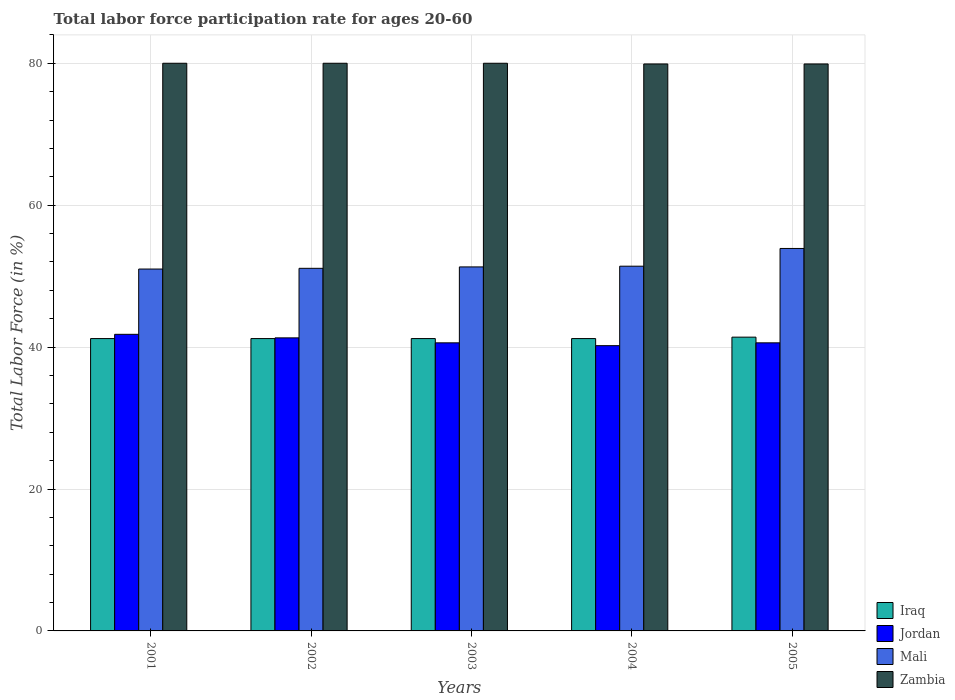How many bars are there on the 4th tick from the right?
Offer a terse response. 4. What is the labor force participation rate in Iraq in 2004?
Give a very brief answer. 41.2. Across all years, what is the maximum labor force participation rate in Iraq?
Your answer should be compact. 41.4. Across all years, what is the minimum labor force participation rate in Jordan?
Keep it short and to the point. 40.2. In which year was the labor force participation rate in Mali minimum?
Offer a terse response. 2001. What is the total labor force participation rate in Iraq in the graph?
Your response must be concise. 206.2. What is the difference between the labor force participation rate in Jordan in 2002 and that in 2005?
Your answer should be very brief. 0.7. What is the difference between the labor force participation rate in Zambia in 2001 and the labor force participation rate in Jordan in 2004?
Offer a terse response. 39.8. What is the average labor force participation rate in Iraq per year?
Your answer should be compact. 41.24. In the year 2003, what is the difference between the labor force participation rate in Mali and labor force participation rate in Jordan?
Keep it short and to the point. 10.7. What is the ratio of the labor force participation rate in Zambia in 2002 to that in 2005?
Offer a very short reply. 1. What is the difference between the highest and the second highest labor force participation rate in Iraq?
Your response must be concise. 0.2. What is the difference between the highest and the lowest labor force participation rate in Zambia?
Your answer should be very brief. 0.1. Is the sum of the labor force participation rate in Zambia in 2004 and 2005 greater than the maximum labor force participation rate in Mali across all years?
Your response must be concise. Yes. Is it the case that in every year, the sum of the labor force participation rate in Zambia and labor force participation rate in Jordan is greater than the sum of labor force participation rate in Mali and labor force participation rate in Iraq?
Ensure brevity in your answer.  Yes. What does the 1st bar from the left in 2005 represents?
Your answer should be very brief. Iraq. What does the 4th bar from the right in 2004 represents?
Offer a very short reply. Iraq. Is it the case that in every year, the sum of the labor force participation rate in Iraq and labor force participation rate in Mali is greater than the labor force participation rate in Jordan?
Provide a short and direct response. Yes. How many bars are there?
Provide a short and direct response. 20. Are all the bars in the graph horizontal?
Give a very brief answer. No. How many years are there in the graph?
Your answer should be very brief. 5. What is the difference between two consecutive major ticks on the Y-axis?
Provide a short and direct response. 20. Does the graph contain any zero values?
Offer a very short reply. No. How many legend labels are there?
Offer a very short reply. 4. How are the legend labels stacked?
Keep it short and to the point. Vertical. What is the title of the graph?
Keep it short and to the point. Total labor force participation rate for ages 20-60. Does "Trinidad and Tobago" appear as one of the legend labels in the graph?
Offer a very short reply. No. What is the label or title of the X-axis?
Your response must be concise. Years. What is the Total Labor Force (in %) of Iraq in 2001?
Ensure brevity in your answer.  41.2. What is the Total Labor Force (in %) in Jordan in 2001?
Your response must be concise. 41.8. What is the Total Labor Force (in %) of Iraq in 2002?
Keep it short and to the point. 41.2. What is the Total Labor Force (in %) in Jordan in 2002?
Your answer should be very brief. 41.3. What is the Total Labor Force (in %) in Mali in 2002?
Your answer should be very brief. 51.1. What is the Total Labor Force (in %) of Iraq in 2003?
Offer a very short reply. 41.2. What is the Total Labor Force (in %) in Jordan in 2003?
Keep it short and to the point. 40.6. What is the Total Labor Force (in %) in Mali in 2003?
Provide a short and direct response. 51.3. What is the Total Labor Force (in %) in Zambia in 2003?
Offer a very short reply. 80. What is the Total Labor Force (in %) of Iraq in 2004?
Ensure brevity in your answer.  41.2. What is the Total Labor Force (in %) of Jordan in 2004?
Your response must be concise. 40.2. What is the Total Labor Force (in %) in Mali in 2004?
Provide a succinct answer. 51.4. What is the Total Labor Force (in %) in Zambia in 2004?
Offer a very short reply. 79.9. What is the Total Labor Force (in %) of Iraq in 2005?
Provide a succinct answer. 41.4. What is the Total Labor Force (in %) of Jordan in 2005?
Your response must be concise. 40.6. What is the Total Labor Force (in %) in Mali in 2005?
Offer a terse response. 53.9. What is the Total Labor Force (in %) in Zambia in 2005?
Offer a terse response. 79.9. Across all years, what is the maximum Total Labor Force (in %) in Iraq?
Your answer should be compact. 41.4. Across all years, what is the maximum Total Labor Force (in %) in Jordan?
Offer a terse response. 41.8. Across all years, what is the maximum Total Labor Force (in %) in Mali?
Your answer should be very brief. 53.9. Across all years, what is the maximum Total Labor Force (in %) of Zambia?
Offer a very short reply. 80. Across all years, what is the minimum Total Labor Force (in %) of Iraq?
Offer a terse response. 41.2. Across all years, what is the minimum Total Labor Force (in %) of Jordan?
Provide a succinct answer. 40.2. Across all years, what is the minimum Total Labor Force (in %) in Mali?
Your answer should be very brief. 51. Across all years, what is the minimum Total Labor Force (in %) of Zambia?
Give a very brief answer. 79.9. What is the total Total Labor Force (in %) in Iraq in the graph?
Keep it short and to the point. 206.2. What is the total Total Labor Force (in %) in Jordan in the graph?
Your response must be concise. 204.5. What is the total Total Labor Force (in %) in Mali in the graph?
Offer a very short reply. 258.7. What is the total Total Labor Force (in %) of Zambia in the graph?
Your answer should be compact. 399.8. What is the difference between the Total Labor Force (in %) of Iraq in 2001 and that in 2002?
Offer a very short reply. 0. What is the difference between the Total Labor Force (in %) in Jordan in 2001 and that in 2002?
Keep it short and to the point. 0.5. What is the difference between the Total Labor Force (in %) in Mali in 2001 and that in 2002?
Your answer should be compact. -0.1. What is the difference between the Total Labor Force (in %) in Zambia in 2001 and that in 2003?
Ensure brevity in your answer.  0. What is the difference between the Total Labor Force (in %) in Mali in 2001 and that in 2004?
Your answer should be very brief. -0.4. What is the difference between the Total Labor Force (in %) in Iraq in 2001 and that in 2005?
Ensure brevity in your answer.  -0.2. What is the difference between the Total Labor Force (in %) of Jordan in 2001 and that in 2005?
Give a very brief answer. 1.2. What is the difference between the Total Labor Force (in %) of Mali in 2001 and that in 2005?
Offer a very short reply. -2.9. What is the difference between the Total Labor Force (in %) in Jordan in 2002 and that in 2003?
Your answer should be very brief. 0.7. What is the difference between the Total Labor Force (in %) in Zambia in 2002 and that in 2003?
Your answer should be compact. 0. What is the difference between the Total Labor Force (in %) of Iraq in 2002 and that in 2004?
Your answer should be very brief. 0. What is the difference between the Total Labor Force (in %) in Jordan in 2002 and that in 2004?
Provide a short and direct response. 1.1. What is the difference between the Total Labor Force (in %) of Mali in 2002 and that in 2004?
Make the answer very short. -0.3. What is the difference between the Total Labor Force (in %) of Mali in 2002 and that in 2005?
Offer a very short reply. -2.8. What is the difference between the Total Labor Force (in %) of Zambia in 2002 and that in 2005?
Give a very brief answer. 0.1. What is the difference between the Total Labor Force (in %) in Iraq in 2003 and that in 2004?
Your answer should be very brief. 0. What is the difference between the Total Labor Force (in %) in Jordan in 2003 and that in 2004?
Your response must be concise. 0.4. What is the difference between the Total Labor Force (in %) of Mali in 2003 and that in 2004?
Ensure brevity in your answer.  -0.1. What is the difference between the Total Labor Force (in %) of Zambia in 2003 and that in 2004?
Your answer should be very brief. 0.1. What is the difference between the Total Labor Force (in %) in Zambia in 2003 and that in 2005?
Provide a succinct answer. 0.1. What is the difference between the Total Labor Force (in %) in Jordan in 2004 and that in 2005?
Your answer should be very brief. -0.4. What is the difference between the Total Labor Force (in %) of Zambia in 2004 and that in 2005?
Make the answer very short. 0. What is the difference between the Total Labor Force (in %) in Iraq in 2001 and the Total Labor Force (in %) in Zambia in 2002?
Provide a succinct answer. -38.8. What is the difference between the Total Labor Force (in %) of Jordan in 2001 and the Total Labor Force (in %) of Zambia in 2002?
Provide a succinct answer. -38.2. What is the difference between the Total Labor Force (in %) in Iraq in 2001 and the Total Labor Force (in %) in Jordan in 2003?
Your answer should be very brief. 0.6. What is the difference between the Total Labor Force (in %) in Iraq in 2001 and the Total Labor Force (in %) in Zambia in 2003?
Ensure brevity in your answer.  -38.8. What is the difference between the Total Labor Force (in %) of Jordan in 2001 and the Total Labor Force (in %) of Zambia in 2003?
Offer a very short reply. -38.2. What is the difference between the Total Labor Force (in %) in Mali in 2001 and the Total Labor Force (in %) in Zambia in 2003?
Your response must be concise. -29. What is the difference between the Total Labor Force (in %) of Iraq in 2001 and the Total Labor Force (in %) of Mali in 2004?
Make the answer very short. -10.2. What is the difference between the Total Labor Force (in %) of Iraq in 2001 and the Total Labor Force (in %) of Zambia in 2004?
Keep it short and to the point. -38.7. What is the difference between the Total Labor Force (in %) in Jordan in 2001 and the Total Labor Force (in %) in Zambia in 2004?
Your response must be concise. -38.1. What is the difference between the Total Labor Force (in %) in Mali in 2001 and the Total Labor Force (in %) in Zambia in 2004?
Your response must be concise. -28.9. What is the difference between the Total Labor Force (in %) in Iraq in 2001 and the Total Labor Force (in %) in Zambia in 2005?
Keep it short and to the point. -38.7. What is the difference between the Total Labor Force (in %) in Jordan in 2001 and the Total Labor Force (in %) in Zambia in 2005?
Your response must be concise. -38.1. What is the difference between the Total Labor Force (in %) in Mali in 2001 and the Total Labor Force (in %) in Zambia in 2005?
Offer a very short reply. -28.9. What is the difference between the Total Labor Force (in %) in Iraq in 2002 and the Total Labor Force (in %) in Jordan in 2003?
Provide a succinct answer. 0.6. What is the difference between the Total Labor Force (in %) in Iraq in 2002 and the Total Labor Force (in %) in Mali in 2003?
Give a very brief answer. -10.1. What is the difference between the Total Labor Force (in %) of Iraq in 2002 and the Total Labor Force (in %) of Zambia in 2003?
Your answer should be compact. -38.8. What is the difference between the Total Labor Force (in %) in Jordan in 2002 and the Total Labor Force (in %) in Zambia in 2003?
Your response must be concise. -38.7. What is the difference between the Total Labor Force (in %) in Mali in 2002 and the Total Labor Force (in %) in Zambia in 2003?
Make the answer very short. -28.9. What is the difference between the Total Labor Force (in %) of Iraq in 2002 and the Total Labor Force (in %) of Zambia in 2004?
Provide a succinct answer. -38.7. What is the difference between the Total Labor Force (in %) of Jordan in 2002 and the Total Labor Force (in %) of Zambia in 2004?
Provide a succinct answer. -38.6. What is the difference between the Total Labor Force (in %) of Mali in 2002 and the Total Labor Force (in %) of Zambia in 2004?
Provide a short and direct response. -28.8. What is the difference between the Total Labor Force (in %) in Iraq in 2002 and the Total Labor Force (in %) in Mali in 2005?
Ensure brevity in your answer.  -12.7. What is the difference between the Total Labor Force (in %) in Iraq in 2002 and the Total Labor Force (in %) in Zambia in 2005?
Ensure brevity in your answer.  -38.7. What is the difference between the Total Labor Force (in %) of Jordan in 2002 and the Total Labor Force (in %) of Zambia in 2005?
Your answer should be compact. -38.6. What is the difference between the Total Labor Force (in %) of Mali in 2002 and the Total Labor Force (in %) of Zambia in 2005?
Your response must be concise. -28.8. What is the difference between the Total Labor Force (in %) in Iraq in 2003 and the Total Labor Force (in %) in Zambia in 2004?
Offer a very short reply. -38.7. What is the difference between the Total Labor Force (in %) in Jordan in 2003 and the Total Labor Force (in %) in Zambia in 2004?
Ensure brevity in your answer.  -39.3. What is the difference between the Total Labor Force (in %) of Mali in 2003 and the Total Labor Force (in %) of Zambia in 2004?
Your answer should be compact. -28.6. What is the difference between the Total Labor Force (in %) in Iraq in 2003 and the Total Labor Force (in %) in Jordan in 2005?
Give a very brief answer. 0.6. What is the difference between the Total Labor Force (in %) of Iraq in 2003 and the Total Labor Force (in %) of Zambia in 2005?
Make the answer very short. -38.7. What is the difference between the Total Labor Force (in %) of Jordan in 2003 and the Total Labor Force (in %) of Mali in 2005?
Offer a terse response. -13.3. What is the difference between the Total Labor Force (in %) in Jordan in 2003 and the Total Labor Force (in %) in Zambia in 2005?
Your answer should be compact. -39.3. What is the difference between the Total Labor Force (in %) of Mali in 2003 and the Total Labor Force (in %) of Zambia in 2005?
Offer a very short reply. -28.6. What is the difference between the Total Labor Force (in %) in Iraq in 2004 and the Total Labor Force (in %) in Jordan in 2005?
Give a very brief answer. 0.6. What is the difference between the Total Labor Force (in %) in Iraq in 2004 and the Total Labor Force (in %) in Mali in 2005?
Ensure brevity in your answer.  -12.7. What is the difference between the Total Labor Force (in %) in Iraq in 2004 and the Total Labor Force (in %) in Zambia in 2005?
Offer a terse response. -38.7. What is the difference between the Total Labor Force (in %) of Jordan in 2004 and the Total Labor Force (in %) of Mali in 2005?
Provide a short and direct response. -13.7. What is the difference between the Total Labor Force (in %) of Jordan in 2004 and the Total Labor Force (in %) of Zambia in 2005?
Your response must be concise. -39.7. What is the difference between the Total Labor Force (in %) of Mali in 2004 and the Total Labor Force (in %) of Zambia in 2005?
Your answer should be compact. -28.5. What is the average Total Labor Force (in %) of Iraq per year?
Keep it short and to the point. 41.24. What is the average Total Labor Force (in %) of Jordan per year?
Your answer should be compact. 40.9. What is the average Total Labor Force (in %) of Mali per year?
Ensure brevity in your answer.  51.74. What is the average Total Labor Force (in %) of Zambia per year?
Provide a succinct answer. 79.96. In the year 2001, what is the difference between the Total Labor Force (in %) in Iraq and Total Labor Force (in %) in Zambia?
Offer a very short reply. -38.8. In the year 2001, what is the difference between the Total Labor Force (in %) of Jordan and Total Labor Force (in %) of Mali?
Your answer should be compact. -9.2. In the year 2001, what is the difference between the Total Labor Force (in %) in Jordan and Total Labor Force (in %) in Zambia?
Give a very brief answer. -38.2. In the year 2001, what is the difference between the Total Labor Force (in %) in Mali and Total Labor Force (in %) in Zambia?
Give a very brief answer. -29. In the year 2002, what is the difference between the Total Labor Force (in %) of Iraq and Total Labor Force (in %) of Zambia?
Provide a short and direct response. -38.8. In the year 2002, what is the difference between the Total Labor Force (in %) in Jordan and Total Labor Force (in %) in Zambia?
Give a very brief answer. -38.7. In the year 2002, what is the difference between the Total Labor Force (in %) in Mali and Total Labor Force (in %) in Zambia?
Your response must be concise. -28.9. In the year 2003, what is the difference between the Total Labor Force (in %) of Iraq and Total Labor Force (in %) of Zambia?
Keep it short and to the point. -38.8. In the year 2003, what is the difference between the Total Labor Force (in %) of Jordan and Total Labor Force (in %) of Zambia?
Offer a very short reply. -39.4. In the year 2003, what is the difference between the Total Labor Force (in %) in Mali and Total Labor Force (in %) in Zambia?
Ensure brevity in your answer.  -28.7. In the year 2004, what is the difference between the Total Labor Force (in %) of Iraq and Total Labor Force (in %) of Mali?
Provide a succinct answer. -10.2. In the year 2004, what is the difference between the Total Labor Force (in %) in Iraq and Total Labor Force (in %) in Zambia?
Offer a very short reply. -38.7. In the year 2004, what is the difference between the Total Labor Force (in %) in Jordan and Total Labor Force (in %) in Mali?
Make the answer very short. -11.2. In the year 2004, what is the difference between the Total Labor Force (in %) of Jordan and Total Labor Force (in %) of Zambia?
Make the answer very short. -39.7. In the year 2004, what is the difference between the Total Labor Force (in %) in Mali and Total Labor Force (in %) in Zambia?
Your answer should be compact. -28.5. In the year 2005, what is the difference between the Total Labor Force (in %) in Iraq and Total Labor Force (in %) in Zambia?
Your answer should be compact. -38.5. In the year 2005, what is the difference between the Total Labor Force (in %) in Jordan and Total Labor Force (in %) in Mali?
Give a very brief answer. -13.3. In the year 2005, what is the difference between the Total Labor Force (in %) in Jordan and Total Labor Force (in %) in Zambia?
Offer a terse response. -39.3. What is the ratio of the Total Labor Force (in %) in Jordan in 2001 to that in 2002?
Keep it short and to the point. 1.01. What is the ratio of the Total Labor Force (in %) of Mali in 2001 to that in 2002?
Provide a short and direct response. 1. What is the ratio of the Total Labor Force (in %) in Zambia in 2001 to that in 2002?
Make the answer very short. 1. What is the ratio of the Total Labor Force (in %) of Jordan in 2001 to that in 2003?
Offer a very short reply. 1.03. What is the ratio of the Total Labor Force (in %) of Mali in 2001 to that in 2003?
Provide a succinct answer. 0.99. What is the ratio of the Total Labor Force (in %) in Zambia in 2001 to that in 2003?
Make the answer very short. 1. What is the ratio of the Total Labor Force (in %) in Jordan in 2001 to that in 2004?
Keep it short and to the point. 1.04. What is the ratio of the Total Labor Force (in %) of Mali in 2001 to that in 2004?
Your response must be concise. 0.99. What is the ratio of the Total Labor Force (in %) of Zambia in 2001 to that in 2004?
Make the answer very short. 1. What is the ratio of the Total Labor Force (in %) in Jordan in 2001 to that in 2005?
Offer a terse response. 1.03. What is the ratio of the Total Labor Force (in %) of Mali in 2001 to that in 2005?
Your response must be concise. 0.95. What is the ratio of the Total Labor Force (in %) in Zambia in 2001 to that in 2005?
Provide a short and direct response. 1. What is the ratio of the Total Labor Force (in %) in Iraq in 2002 to that in 2003?
Offer a terse response. 1. What is the ratio of the Total Labor Force (in %) in Jordan in 2002 to that in 2003?
Your response must be concise. 1.02. What is the ratio of the Total Labor Force (in %) in Mali in 2002 to that in 2003?
Give a very brief answer. 1. What is the ratio of the Total Labor Force (in %) of Iraq in 2002 to that in 2004?
Your answer should be compact. 1. What is the ratio of the Total Labor Force (in %) in Jordan in 2002 to that in 2004?
Offer a very short reply. 1.03. What is the ratio of the Total Labor Force (in %) in Zambia in 2002 to that in 2004?
Ensure brevity in your answer.  1. What is the ratio of the Total Labor Force (in %) in Jordan in 2002 to that in 2005?
Keep it short and to the point. 1.02. What is the ratio of the Total Labor Force (in %) of Mali in 2002 to that in 2005?
Give a very brief answer. 0.95. What is the ratio of the Total Labor Force (in %) in Iraq in 2003 to that in 2004?
Ensure brevity in your answer.  1. What is the ratio of the Total Labor Force (in %) of Jordan in 2003 to that in 2005?
Give a very brief answer. 1. What is the ratio of the Total Labor Force (in %) of Mali in 2003 to that in 2005?
Provide a succinct answer. 0.95. What is the ratio of the Total Labor Force (in %) in Jordan in 2004 to that in 2005?
Your answer should be compact. 0.99. What is the ratio of the Total Labor Force (in %) in Mali in 2004 to that in 2005?
Offer a very short reply. 0.95. What is the difference between the highest and the second highest Total Labor Force (in %) in Jordan?
Offer a very short reply. 0.5. What is the difference between the highest and the second highest Total Labor Force (in %) in Mali?
Your response must be concise. 2.5. What is the difference between the highest and the second highest Total Labor Force (in %) of Zambia?
Ensure brevity in your answer.  0. What is the difference between the highest and the lowest Total Labor Force (in %) in Jordan?
Keep it short and to the point. 1.6. 